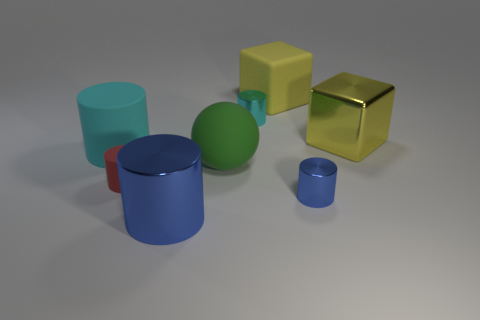The cylinder that is behind the red thing and on the right side of the big cyan matte thing is made of what material?
Your answer should be very brief. Metal. Do the big cyan matte object and the tiny blue metal thing have the same shape?
Give a very brief answer. Yes. Is there anything else that is the same size as the red rubber thing?
Your response must be concise. Yes. There is a big blue object; what number of large shiny things are right of it?
Your answer should be very brief. 1. Do the blue object left of the yellow rubber thing and the tiny cyan thing have the same size?
Give a very brief answer. No. What color is the other small matte thing that is the same shape as the tiny cyan object?
Your answer should be very brief. Red. Is there anything else that is the same shape as the big green matte object?
Provide a short and direct response. No. What shape is the blue thing left of the small blue metal object?
Provide a succinct answer. Cylinder. How many large cyan rubber things have the same shape as the tiny blue object?
Your response must be concise. 1. Do the metallic cylinder on the right side of the large yellow rubber block and the small metallic cylinder left of the yellow rubber cube have the same color?
Make the answer very short. No. 